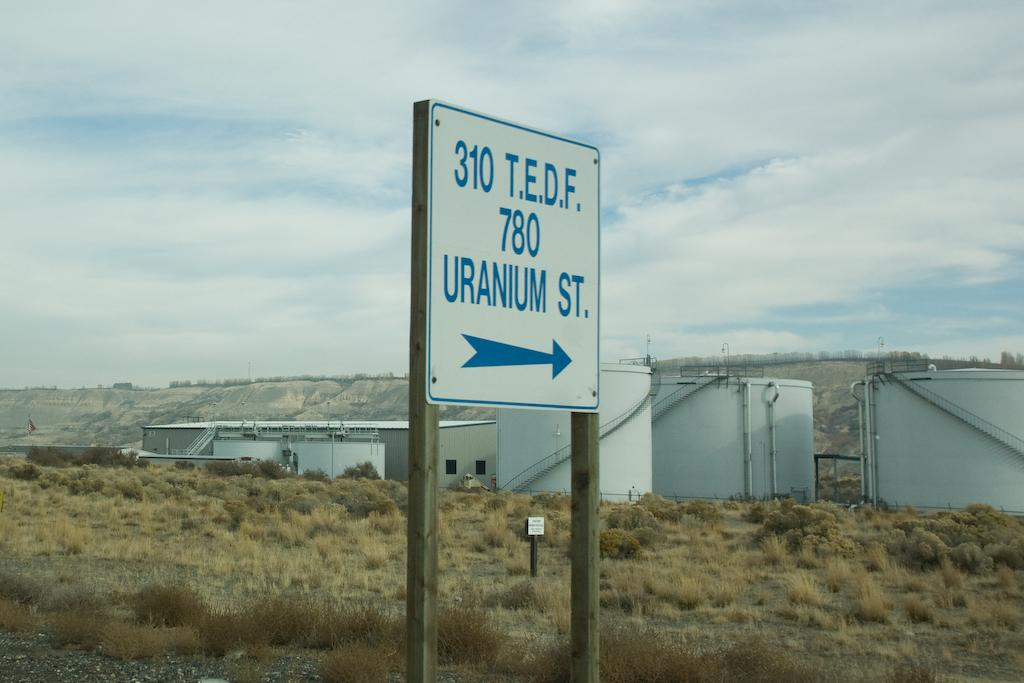<image>
Provide a brief description of the given image. White sign with blue border says 310 T.E.D.F. 780  Uranium St. with blue arrow pointing right. 